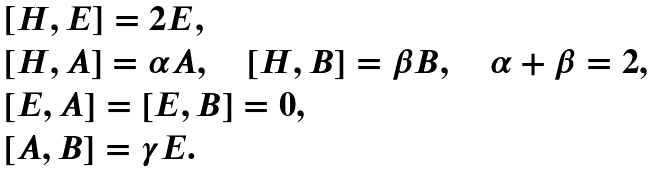Convert formula to latex. <formula><loc_0><loc_0><loc_500><loc_500>\begin{array} { l } \left [ H , E \right ] = 2 E , \\ \left [ H , A \right ] = \alpha A , \quad \left [ H , B \right ] = \beta B , \quad \alpha + \beta = 2 , \\ \left [ E , A \right ] = \left [ E , B \right ] = 0 , \\ \left [ A , B \right ] = \gamma E . \end{array}</formula> 